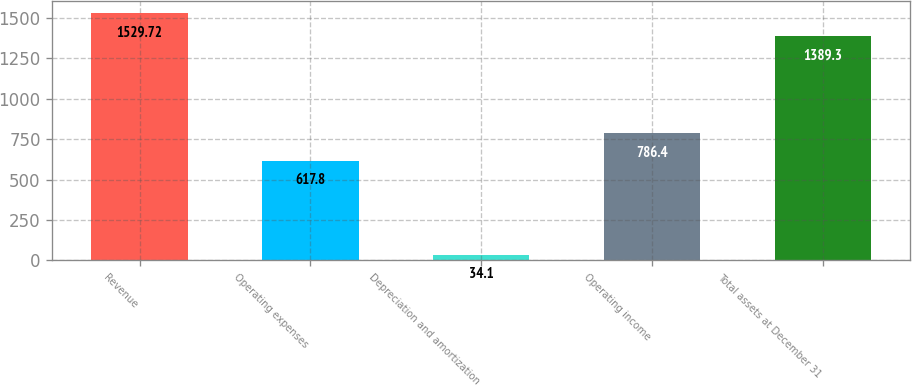Convert chart. <chart><loc_0><loc_0><loc_500><loc_500><bar_chart><fcel>Revenue<fcel>Operating expenses<fcel>Depreciation and amortization<fcel>Operating income<fcel>Total assets at December 31<nl><fcel>1529.72<fcel>617.8<fcel>34.1<fcel>786.4<fcel>1389.3<nl></chart> 